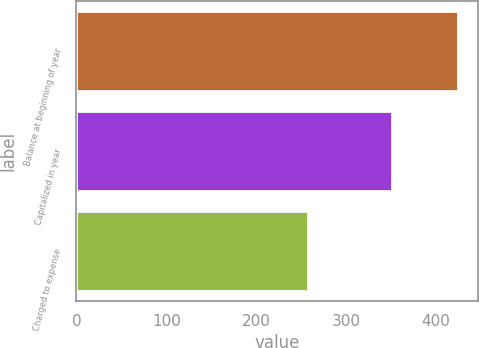Convert chart to OTSL. <chart><loc_0><loc_0><loc_500><loc_500><bar_chart><fcel>Balance at beginning of year<fcel>Capitalized in year<fcel>Charged to expense<nl><fcel>425<fcel>351<fcel>258<nl></chart> 